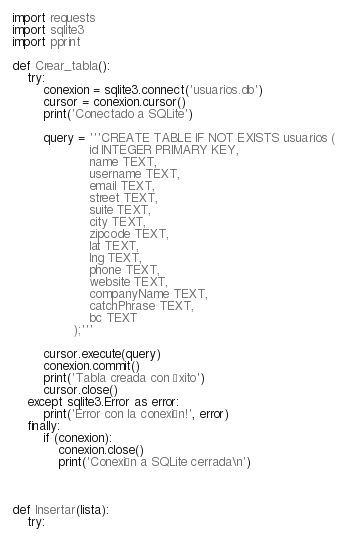Convert code to text. <code><loc_0><loc_0><loc_500><loc_500><_Python_>import requests
import sqlite3
import pprint

def Crear_tabla():
    try:
        conexion = sqlite3.connect('usuarios.db')
        cursor = conexion.cursor()
        print('Conectado a SQLite')

        query = '''CREATE TABLE IF NOT EXISTS usuarios (
                    id INTEGER PRIMARY KEY,
                    name TEXT,
                    username TEXT,
                    email TEXT,
                    street TEXT,
                    suite TEXT,
                    city TEXT,
                    zipcode TEXT,
                    lat TEXT,
                    lng TEXT,
                    phone TEXT,
                    website TEXT,
                    companyName TEXT,
                    catchPhrase TEXT,
                    bc TEXT
                );'''

        cursor.execute(query)
        conexion.commit()
        print('Tabla creada con éxito')
        cursor.close()
    except sqlite3.Error as error:
        print('Error con la conexión!', error)
    finally:
        if (conexion):
            conexion.close()
            print('Conexión a SQLite cerrada\n')



def Insertar(lista):
    try:</code> 